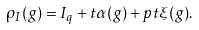<formula> <loc_0><loc_0><loc_500><loc_500>\rho _ { I } ( g ) = I _ { q } + t \alpha ( g ) + p t \xi ( g ) .</formula> 